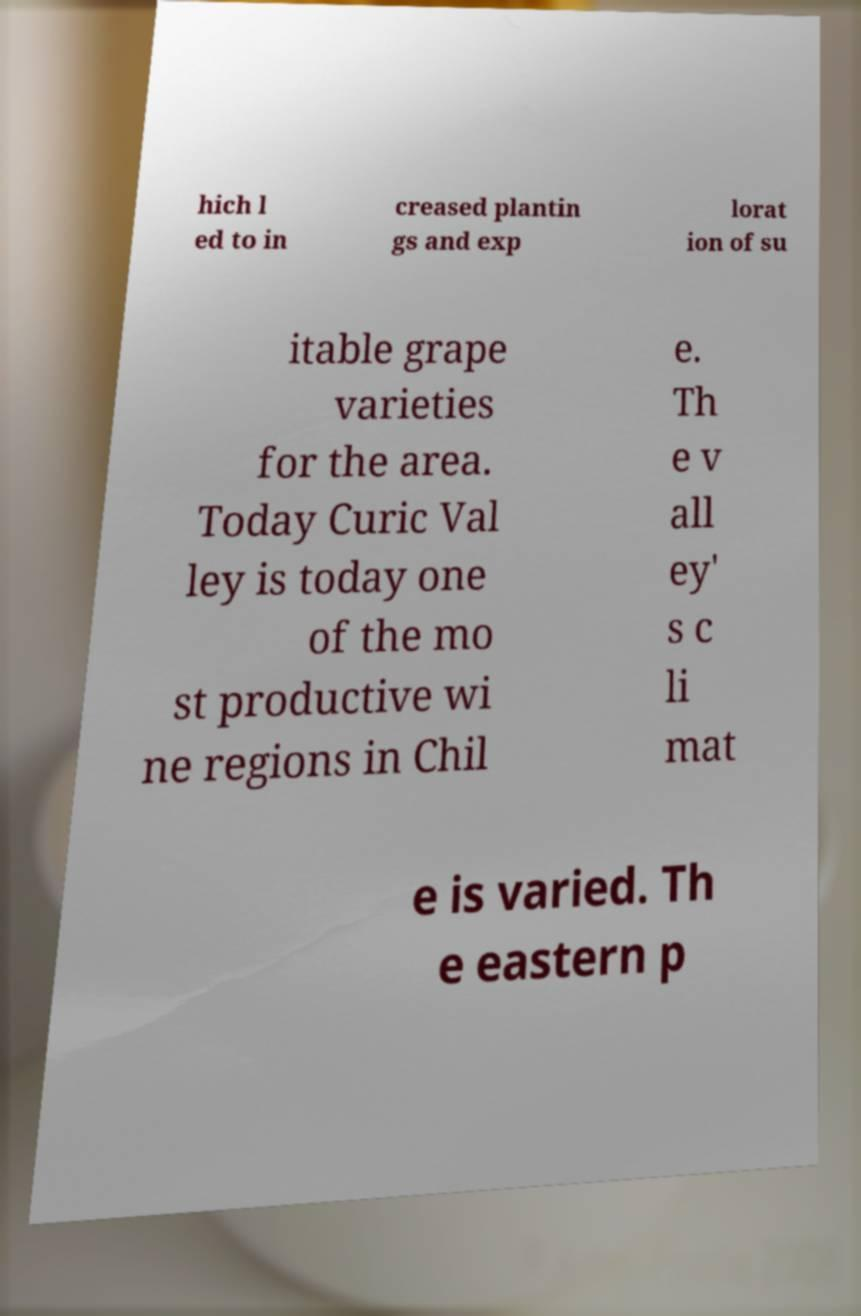Can you read and provide the text displayed in the image?This photo seems to have some interesting text. Can you extract and type it out for me? hich l ed to in creased plantin gs and exp lorat ion of su itable grape varieties for the area. Today Curic Val ley is today one of the mo st productive wi ne regions in Chil e. Th e v all ey' s c li mat e is varied. Th e eastern p 